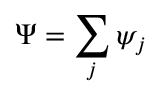Convert formula to latex. <formula><loc_0><loc_0><loc_500><loc_500>\Psi = \sum _ { j } \psi _ { j }</formula> 